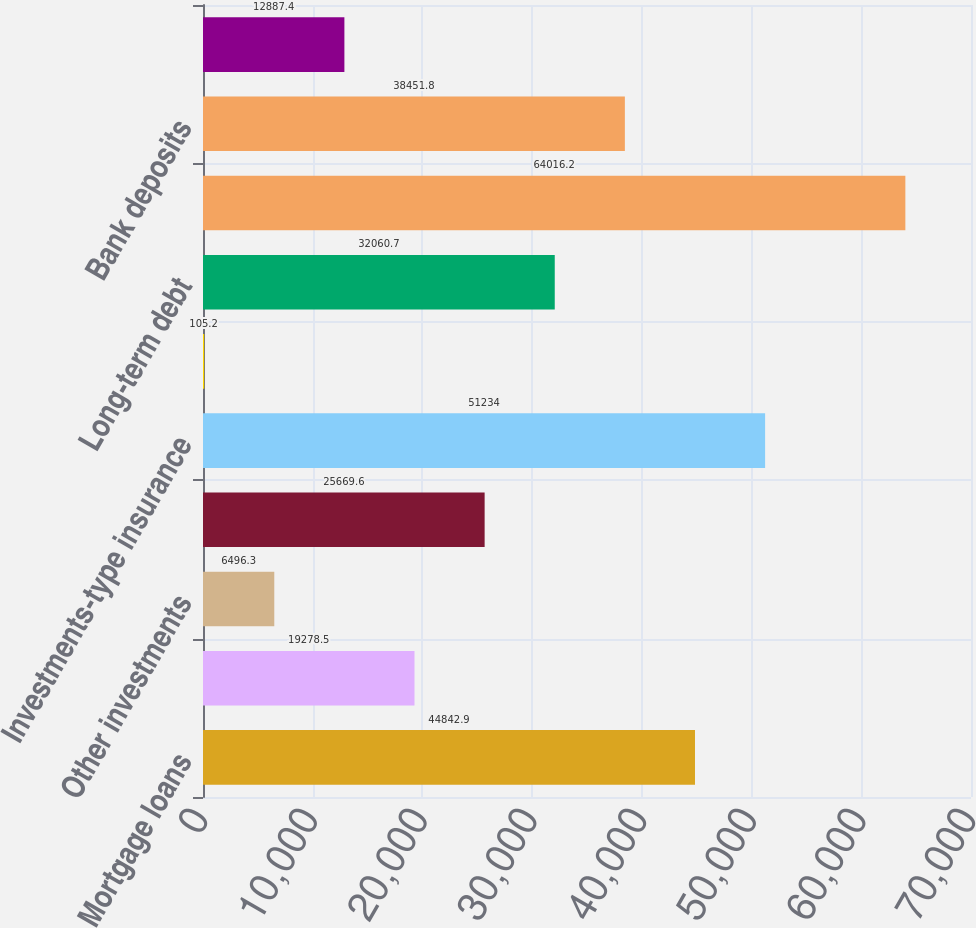Convert chart. <chart><loc_0><loc_0><loc_500><loc_500><bar_chart><fcel>Mortgage loans<fcel>Policy loans<fcel>Other investments<fcel>Cash and cash equivalents<fcel>Investments-type insurance<fcel>Short-term debt<fcel>Long-term debt<fcel>Separate account liabilities<fcel>Bank deposits<fcel>Cash collateral payable<nl><fcel>44842.9<fcel>19278.5<fcel>6496.3<fcel>25669.6<fcel>51234<fcel>105.2<fcel>32060.7<fcel>64016.2<fcel>38451.8<fcel>12887.4<nl></chart> 